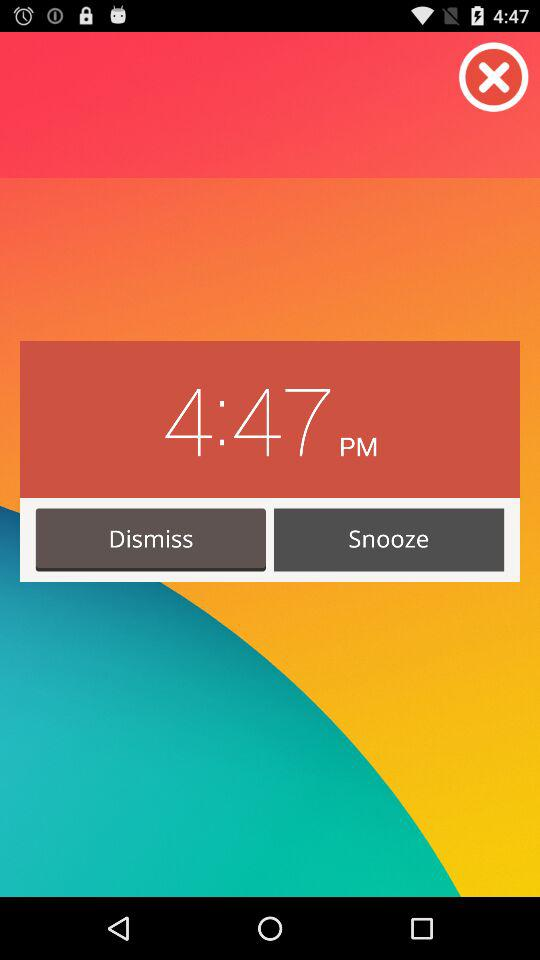What is the alarm time? The alarm time is 4:47 PM. 